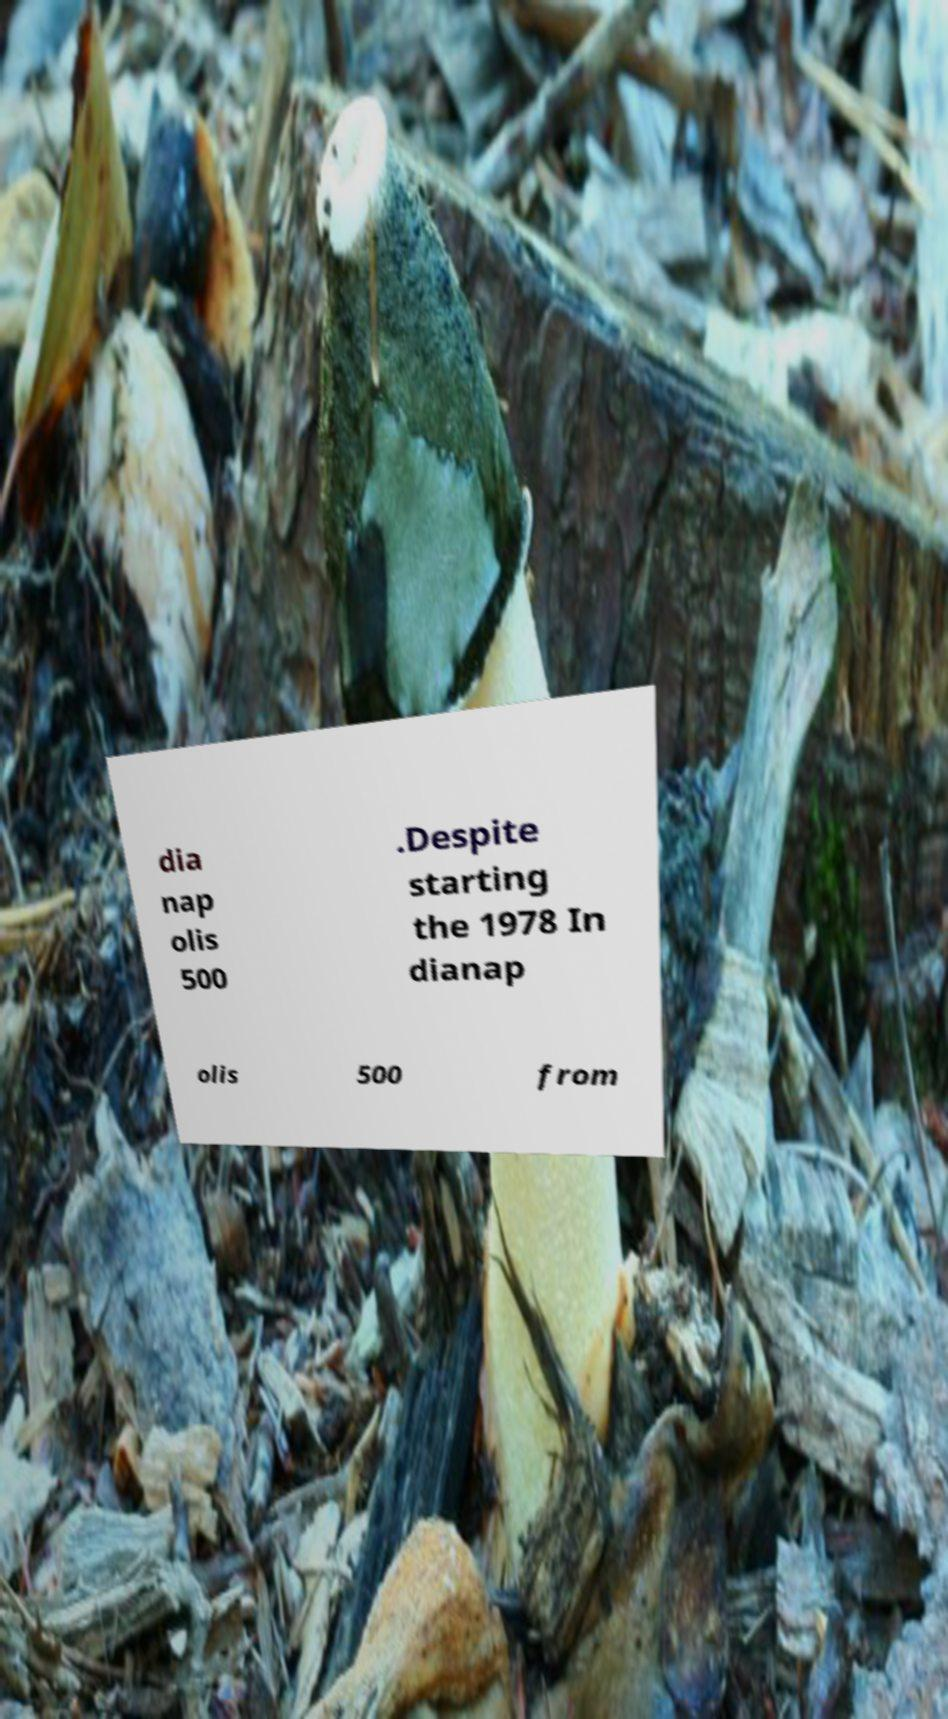Please read and relay the text visible in this image. What does it say? dia nap olis 500 .Despite starting the 1978 In dianap olis 500 from 